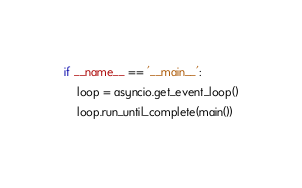<code> <loc_0><loc_0><loc_500><loc_500><_Python_>
if __name__ == '__main__':
    loop = asyncio.get_event_loop()
    loop.run_until_complete(main())</code> 